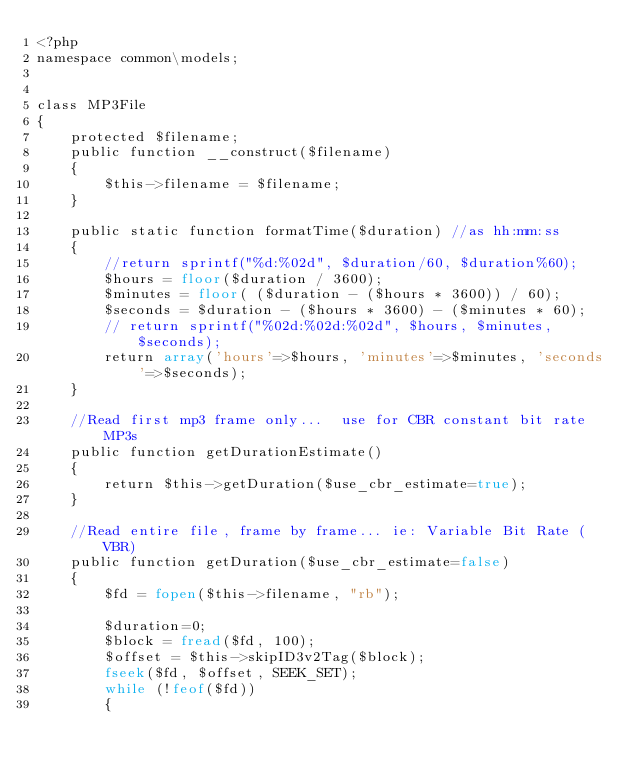<code> <loc_0><loc_0><loc_500><loc_500><_PHP_><?php 
namespace common\models;


class MP3File
{
    protected $filename;
    public function __construct($filename)
    {
        $this->filename = $filename;
    }

    public static function formatTime($duration) //as hh:mm:ss
    {
        //return sprintf("%d:%02d", $duration/60, $duration%60);
        $hours = floor($duration / 3600);
        $minutes = floor( ($duration - ($hours * 3600)) / 60);
        $seconds = $duration - ($hours * 3600) - ($minutes * 60);
        // return sprintf("%02d:%02d:%02d", $hours, $minutes, $seconds);
        return array('hours'=>$hours, 'minutes'=>$minutes, 'seconds'=>$seconds);
    }

    //Read first mp3 frame only...  use for CBR constant bit rate MP3s
    public function getDurationEstimate()
    {
        return $this->getDuration($use_cbr_estimate=true);
    }

    //Read entire file, frame by frame... ie: Variable Bit Rate (VBR)
    public function getDuration($use_cbr_estimate=false)
    {
        $fd = fopen($this->filename, "rb");

        $duration=0;
        $block = fread($fd, 100);
        $offset = $this->skipID3v2Tag($block);
        fseek($fd, $offset, SEEK_SET);
        while (!feof($fd))
        {</code> 